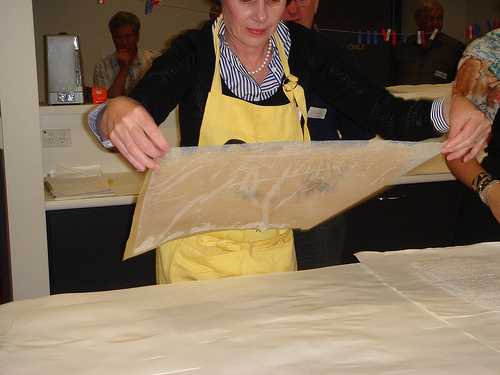<image>
Is there a apron on the man? No. The apron is not positioned on the man. They may be near each other, but the apron is not supported by or resting on top of the man. Is the man in front of the wall? Yes. The man is positioned in front of the wall, appearing closer to the camera viewpoint. 